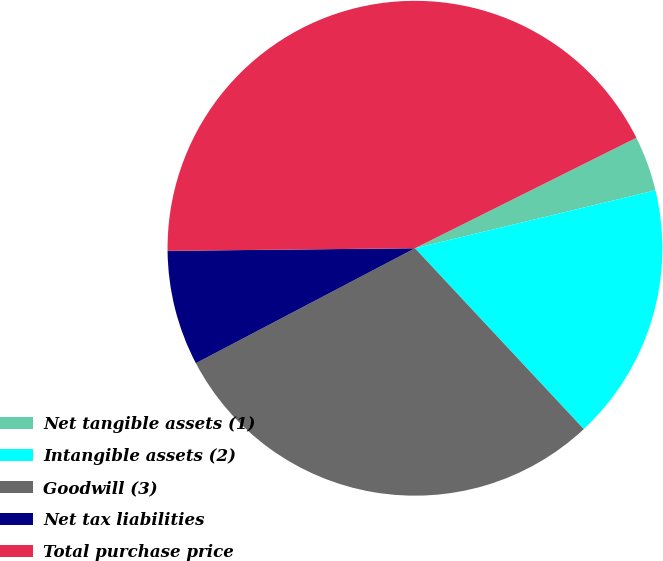<chart> <loc_0><loc_0><loc_500><loc_500><pie_chart><fcel>Net tangible assets (1)<fcel>Intangible assets (2)<fcel>Goodwill (3)<fcel>Net tax liabilities<fcel>Total purchase price<nl><fcel>3.6%<fcel>16.81%<fcel>29.26%<fcel>7.52%<fcel>42.8%<nl></chart> 